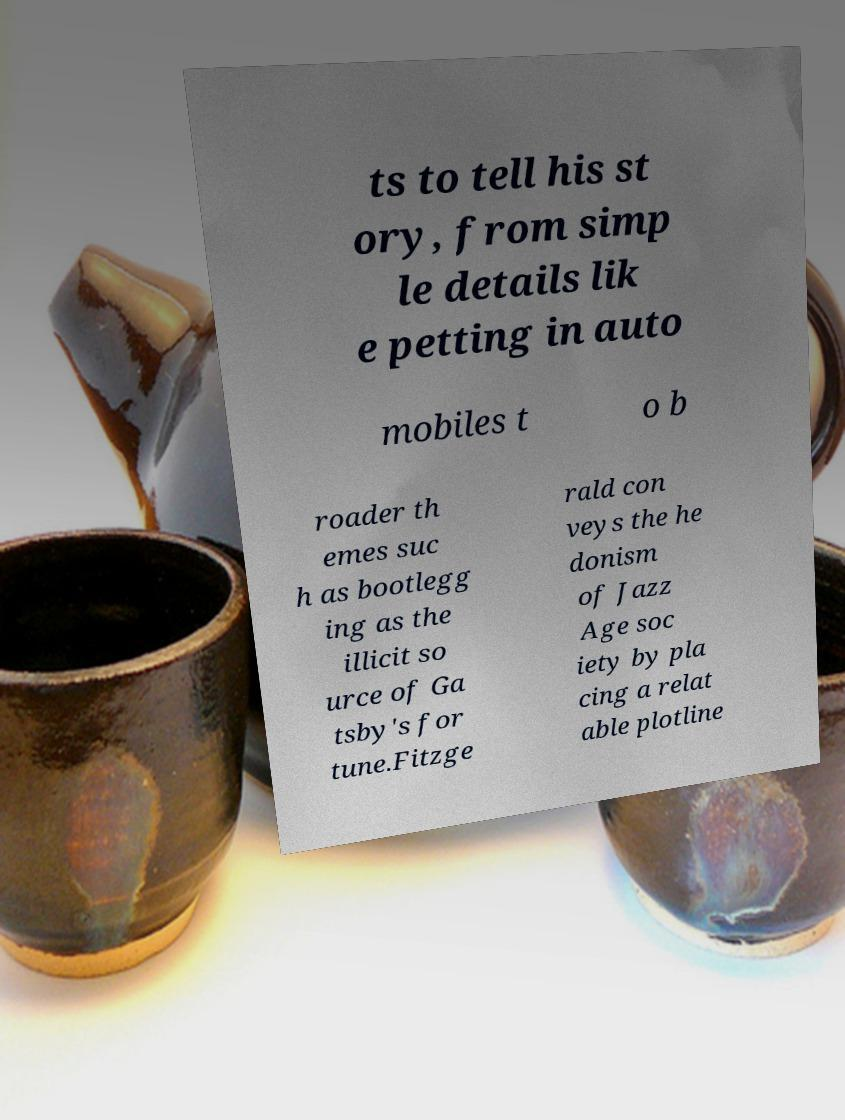Could you extract and type out the text from this image? ts to tell his st ory, from simp le details lik e petting in auto mobiles t o b roader th emes suc h as bootlegg ing as the illicit so urce of Ga tsby's for tune.Fitzge rald con veys the he donism of Jazz Age soc iety by pla cing a relat able plotline 